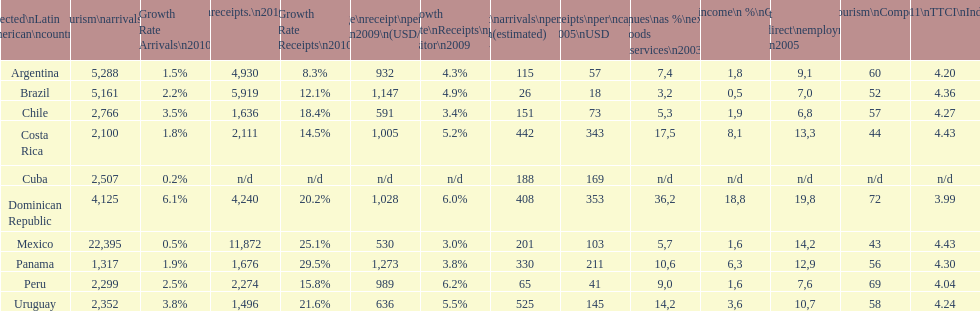Could you help me parse every detail presented in this table? {'header': ['Selected\\nLatin American\\ncountries', 'Internl.\\ntourism\\narrivals\\n2010\\n(x 1000)', 'Growth Rate Arrivals\\n2010', 'Internl.\\ntourism\\nreceipts.\\n2010\\n(USD\\n(x1000)', 'Growth Rate Receipts\\n2010', 'Average\\nreceipt\\nper visitor\\n2009\\n(USD/turista)', 'Growth Rate\\nReceipts\\nper visitor\\n2009', 'Tourist\\narrivals\\nper\\n1000 inhab\\n(estimated) \\n2007', 'Receipts\\nper\\ncapita \\n2005\\nUSD', 'Revenues\\nas\xa0%\\nexports of\\ngoods and\\nservices\\n2003', 'Tourism\\nincome\\n\xa0%\\nGDP\\n2003', '% Direct and\\nindirect\\nemployment\\nin tourism\\n2005', 'World\\nranking\\nTourism\\nCompetitiv.\\nTTCI\\n2011', '2011\\nTTCI\\nIndex'], 'rows': [['Argentina', '5,288', '1.5%', '4,930', '8.3%', '932', '4.3%', '115', '57', '7,4', '1,8', '9,1', '60', '4.20'], ['Brazil', '5,161', '2.2%', '5,919', '12.1%', '1,147', '4.9%', '26', '18', '3,2', '0,5', '7,0', '52', '4.36'], ['Chile', '2,766', '3.5%', '1,636', '18.4%', '591', '3.4%', '151', '73', '5,3', '1,9', '6,8', '57', '4.27'], ['Costa Rica', '2,100', '1.8%', '2,111', '14.5%', '1,005', '5.2%', '442', '343', '17,5', '8,1', '13,3', '44', '4.43'], ['Cuba', '2,507', '0.2%', 'n/d', 'n/d', 'n/d', 'n/d', '188', '169', 'n/d', 'n/d', 'n/d', 'n/d', 'n/d'], ['Dominican Republic', '4,125', '6.1%', '4,240', '20.2%', '1,028', '6.0%', '408', '353', '36,2', '18,8', '19,8', '72', '3.99'], ['Mexico', '22,395', '0.5%', '11,872', '25.1%', '530', '3.0%', '201', '103', '5,7', '1,6', '14,2', '43', '4.43'], ['Panama', '1,317', '1.9%', '1,676', '29.5%', '1,273', '3.8%', '330', '211', '10,6', '6,3', '12,9', '56', '4.30'], ['Peru', '2,299', '2.5%', '2,274', '15.8%', '989', '6.2%', '65', '41', '9,0', '1,6', '7,6', '69', '4.04'], ['Uruguay', '2,352', '3.8%', '1,496', '21.6%', '636', '5.5%', '525', '145', '14,2', '3,6', '10,7', '58', '4.24']]} Which nation had the lowest arrivals per 1000 residents in 2007 (approximated)? Brazil. 